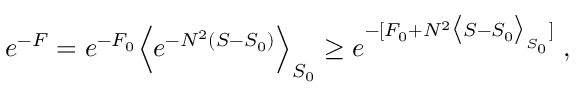Convert formula to latex. <formula><loc_0><loc_0><loc_500><loc_500>e ^ { - F } = e ^ { - F _ { 0 } } \Big < e ^ { - N ^ { 2 } ( S - S _ { 0 } ) } \Big > _ { S _ { 0 } } \geq e ^ { - [ F _ { 0 } + N ^ { 2 } \Big < S - S _ { 0 } \Big > _ { S _ { 0 } } ] } \, ,</formula> 